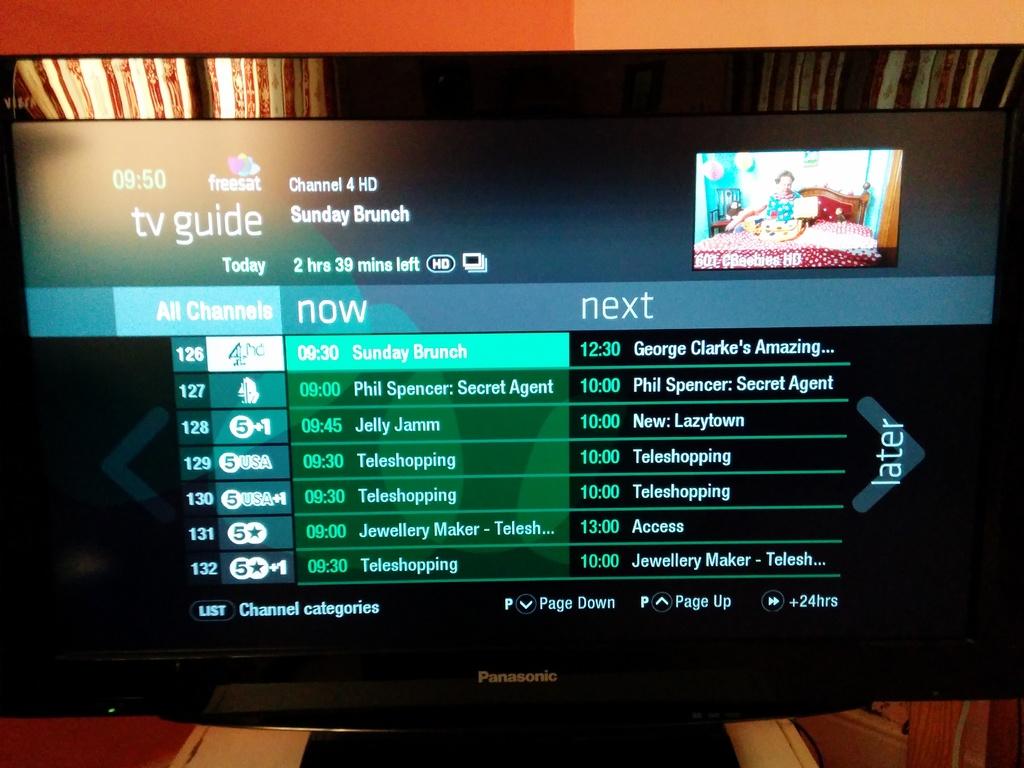What comes on next?
Give a very brief answer. George clarke's amazing. What channel is selected?
Make the answer very short. 126. 